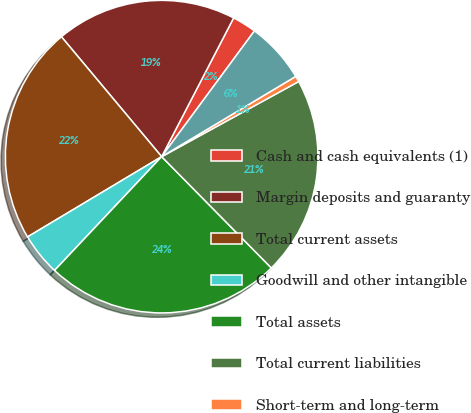Convert chart to OTSL. <chart><loc_0><loc_0><loc_500><loc_500><pie_chart><fcel>Cash and cash equivalents (1)<fcel>Margin deposits and guaranty<fcel>Total current assets<fcel>Goodwill and other intangible<fcel>Total assets<fcel>Total current liabilities<fcel>Short-term and long-term<fcel>Equity (1)<nl><fcel>2.5%<fcel>18.7%<fcel>22.5%<fcel>4.4%<fcel>24.4%<fcel>20.6%<fcel>0.6%<fcel>6.3%<nl></chart> 